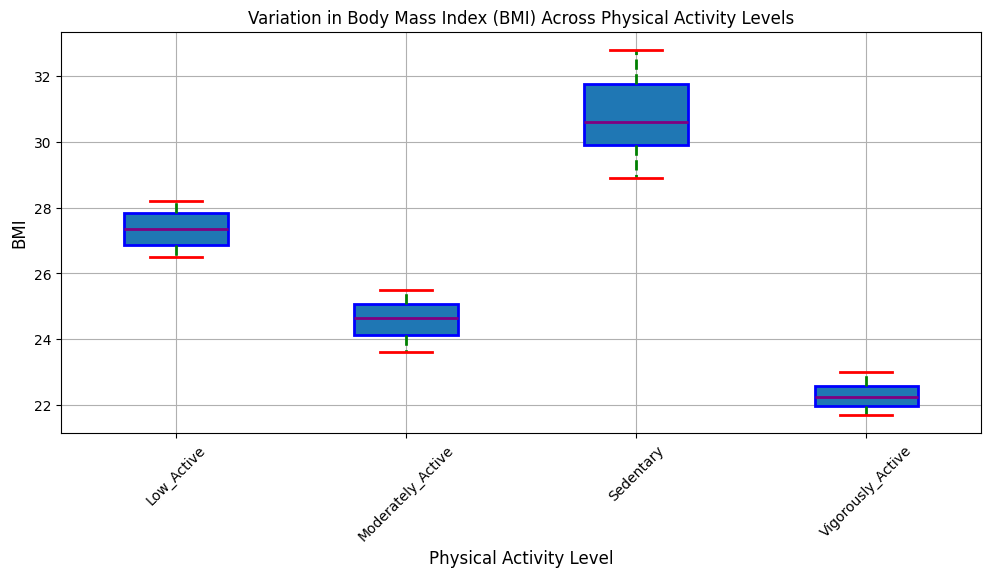What is the median BMI for the Sedentary group? The median BMI for the Sedentary group is indicated by the purple line within the Sedentary box in the plot.
Answer: 30.6 Which Physical Activity Level group has the lowest median BMI? By comparing the purple lines in each group’s box, we can see that the Vigorously Active group has the lowest median BMI.
Answer: Vigorously Active What is the interquartile range (IQR) of BMI for the Moderately Active group? The interquartile range (IQR) is the difference between the third quartile (Q3, the top of the box) and the first quartile (Q1, the bottom of the box). Estimate these values from the plot for the Moderately Active group and subtract Q1 from Q3.
Answer: 1.3 (approximately 25.1 - 23.8) Which group shows the greatest variation in BMI? The variation in BMI is depicted by the length of the whiskers. The Sedentary group's whiskers span the largest range, indicating the greatest variation.
Answer: Sedentary Compare the median BMI of the Low Active group to the Moderately Active group. Which is higher? The median BMI is represented by the purple line inside the box. By comparing these lines, we see that the median BMI of the Low Active group is higher than that of the Moderately Active group.
Answer: Low Active Does the Vigorously Active group have any outliers? Outliers are typically represented as individual points outside the whiskers. By observing the Vigorously Active group, there are no individual points visible outside the whiskers, indicating no outliers.
Answer: No What is the range of BMI values for the Vigorously Active group? The range is the difference between the maximum and minimum BMI values, shown by the end points of the whiskers for the Vigorously Active group. Estimate these points from the plot.
Answer: Approximately 1.3 (23.0 - 21.7) How does the range of BMI values for the Sedentary group compare to that of the Low Active group? By comparing the whisker lengths, the Sedentary group has a longer span than the Low Active group, indicating a larger range of BMI values.
Answer: Sedentary group has a larger range Which group has the smallest interquartile range (IQR)? The IQR is depicted by the height of the box. By visually comparing the boxes, the Vigorously Active group has the smallest IQR.
Answer: Vigorously Active Which group has the highest upper whisker value for BMI? The upper whisker represents the maximum BMI value within 1.5 times the IQR. The Sedentary group has the highest upper whisker value.
Answer: Sedentary 